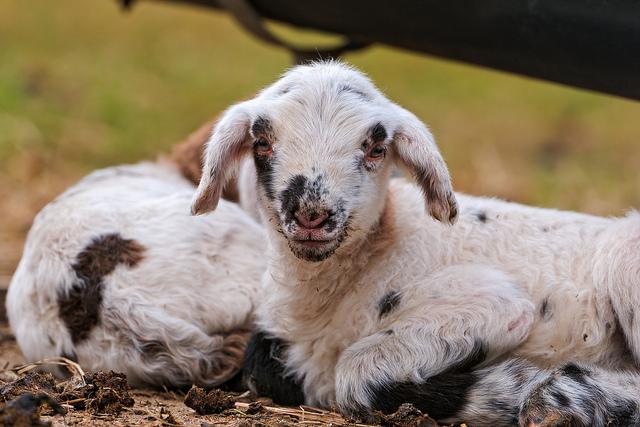Are they laying on the ground?
Be succinct. Yes. Pet or farm animal?
Quick response, please. Farm animal. Is this animal sleeping?
Short answer required. No. 